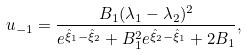Convert formula to latex. <formula><loc_0><loc_0><loc_500><loc_500>u _ { - 1 } = \frac { B _ { 1 } ( \lambda _ { 1 } - \lambda _ { 2 } ) ^ { 2 } } { e ^ { \hat { \xi } _ { 1 } - \hat { \xi } _ { 2 } } + B _ { 1 } ^ { 2 } e ^ { \hat { \xi } _ { 2 } - \hat { \xi } _ { 1 } } + 2 B _ { 1 } } ,</formula> 